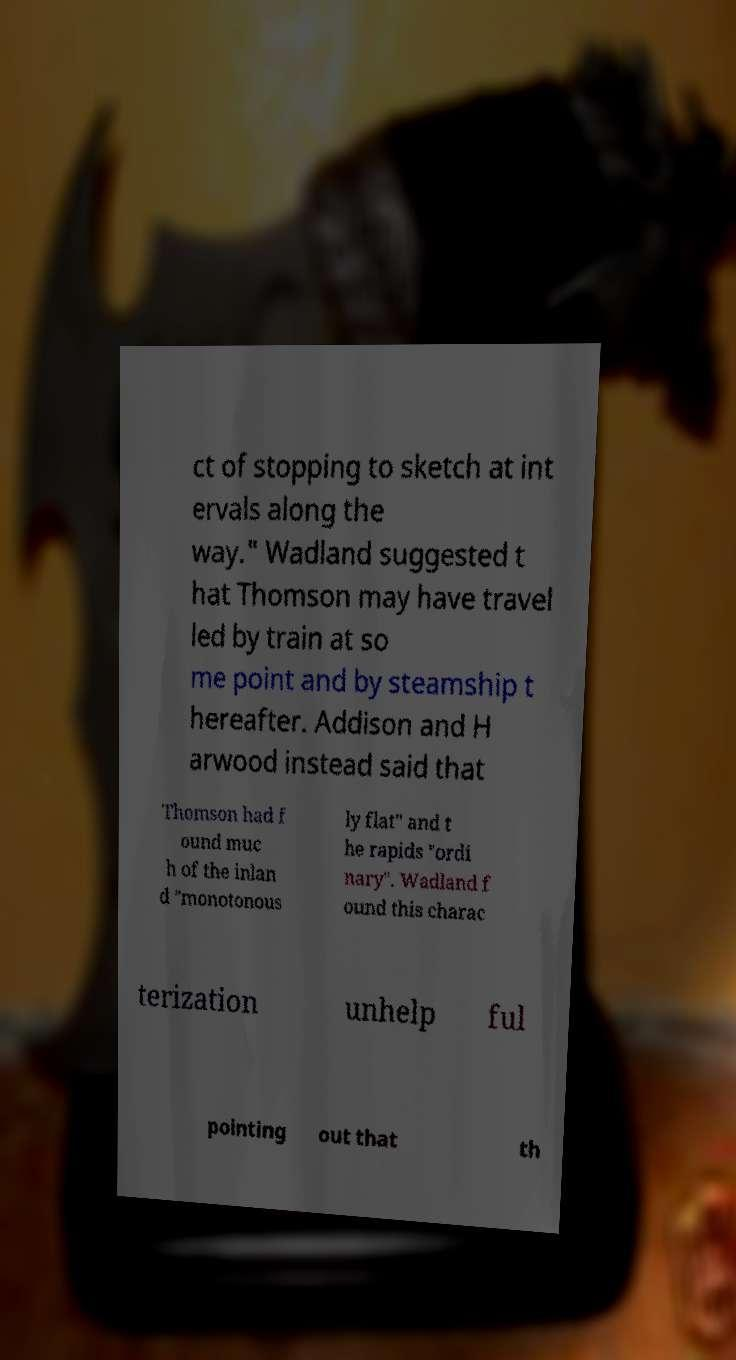Can you read and provide the text displayed in the image?This photo seems to have some interesting text. Can you extract and type it out for me? ct of stopping to sketch at int ervals along the way." Wadland suggested t hat Thomson may have travel led by train at so me point and by steamship t hereafter. Addison and H arwood instead said that Thomson had f ound muc h of the inlan d "monotonous ly flat" and t he rapids "ordi nary". Wadland f ound this charac terization unhelp ful pointing out that th 